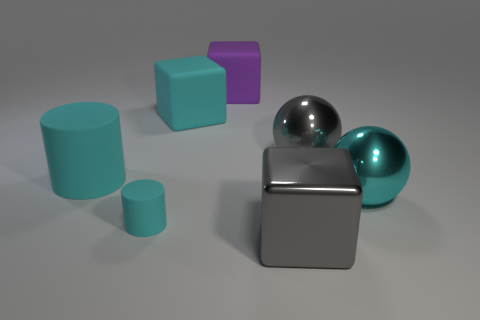Subtract all cyan cubes. How many cubes are left? 2 Subtract all gray spheres. How many spheres are left? 1 Subtract 1 spheres. How many spheres are left? 1 Add 7 large purple cubes. How many large purple cubes exist? 8 Add 3 gray balls. How many objects exist? 10 Subtract 0 yellow cylinders. How many objects are left? 7 Subtract all cylinders. How many objects are left? 5 Subtract all yellow blocks. Subtract all red cylinders. How many blocks are left? 3 Subtract all blue cylinders. How many green cubes are left? 0 Subtract all cyan cylinders. Subtract all cyan blocks. How many objects are left? 4 